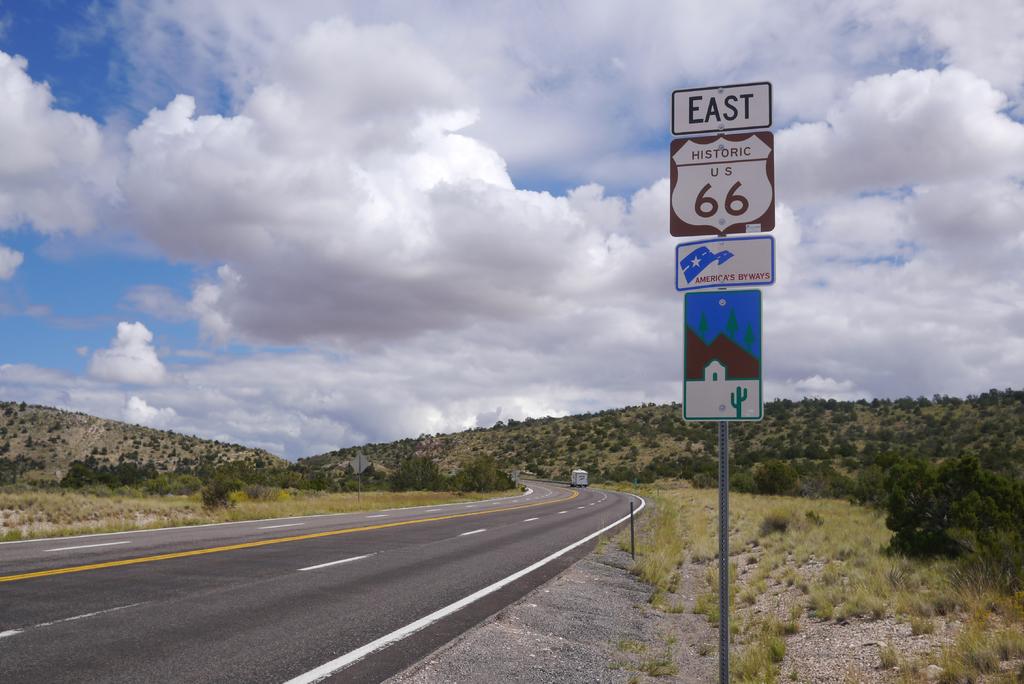What way is this road headed?
Make the answer very short. East. Which highway is this?
Keep it short and to the point. 66. 